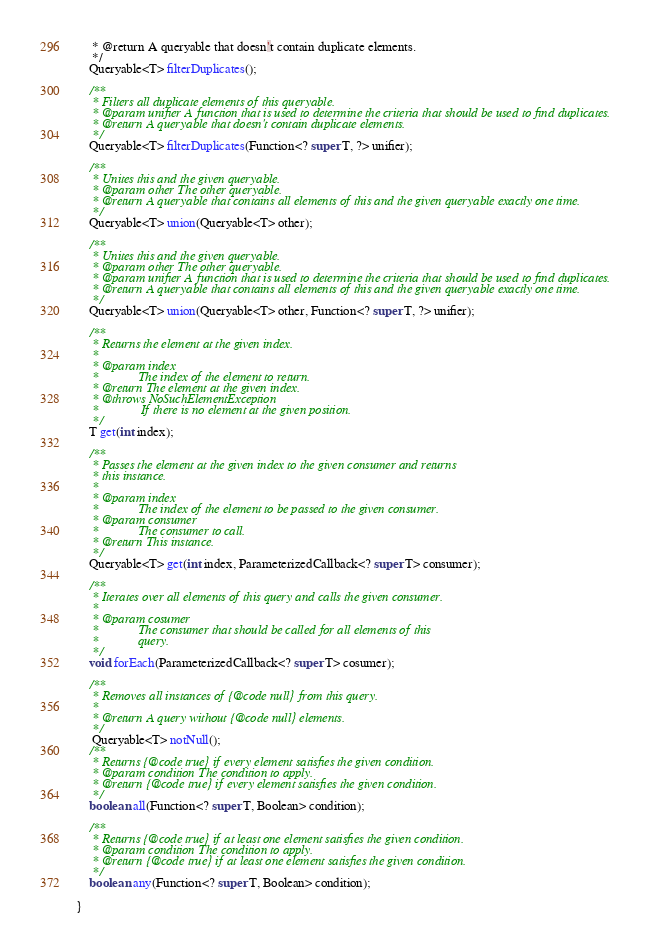<code> <loc_0><loc_0><loc_500><loc_500><_Java_>	 * @return A queryable that doesn't contain duplicate elements.
	 */
	Queryable<T> filterDuplicates();
	
	/**
	 * Filters all duplicate elements of this queryable.
	 * @param unifier A function that is used to determine the criteria that should be used to find duplicates.
	 * @return A queryable that doesn't contain duplicate elements.
	 */
	Queryable<T> filterDuplicates(Function<? super T, ?> unifier);
	
	/**
	 * Unites this and the given queryable.
	 * @param other The other queryable.
	 * @return A queryable that contains all elements of this and the given queryable exactly one time.
	 */
	Queryable<T> union(Queryable<T> other);
	
	/**
	 * Unites this and the given queryable.
	 * @param other The other queryable.
	 * @param unifier A function that is used to determine the criteria that should be used to find duplicates.
	 * @return A queryable that contains all elements of this and the given queryable exactly one time.
	 */
	Queryable<T> union(Queryable<T> other, Function<? super T, ?> unifier);
	
	/**
	 * Returns the element at the given index.
	 * 
	 * @param index
	 *            The index of the element to return.
	 * @return The element at the given index.
	 * @throws NoSuchElementException
	 *             If there is no element at the given position.
	 */
	T get(int index);

	/**
	 * Passes the element at the given index to the given consumer and returns
	 * this instance.
	 * 
	 * @param index
	 *            The index of the element to be passed to the given consumer.
	 * @param consumer
	 *            The consumer to call.
	 * @return This instance.
	 */
	Queryable<T> get(int index, ParameterizedCallback<? super T> consumer);

	/**
	 * Iterates over all elements of this query and calls the given consumer.
	 * 
	 * @param cosumer
	 *            The consumer that should be called for all elements of this
	 *            query.
	 */
	void forEach(ParameterizedCallback<? super T> cosumer);

	/**
	 * Removes all instances of {@code null} from this query.
	 * 
	 * @return A query without {@code null} elements.
	 */
     Queryable<T> notNull();
	/**
	 * Returns {@code true} if every element satisfies the given condition.
	 * @param condition The condition to apply.
	 * @return {@code true} if every element satisfies the given condition. 
	 */
	boolean all(Function<? super T, Boolean> condition);

	/**
	 * Returns {@code true} if at least one element satisfies the given condition.
	 * @param condition The condition to apply.
	 * @return {@code true} if at least one element satisfies the given condition.
	 */
	boolean any(Function<? super T, Boolean> condition);
	
}
</code> 